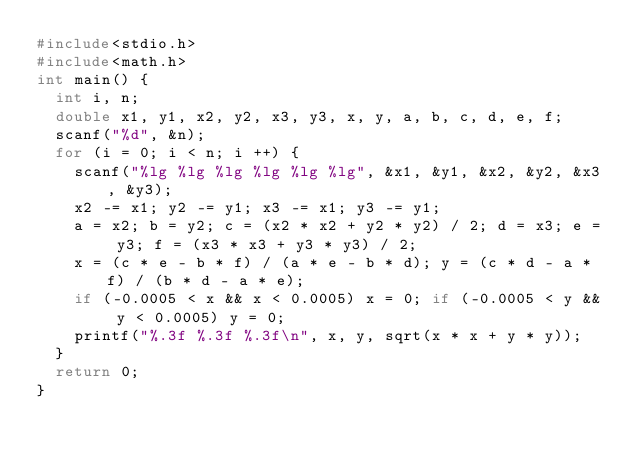<code> <loc_0><loc_0><loc_500><loc_500><_C_>#include<stdio.h>
#include<math.h>
int main() {
  int i, n;
  double x1, y1, x2, y2, x3, y3, x, y, a, b, c, d, e, f;
  scanf("%d", &n);
  for (i = 0; i < n; i ++) {
    scanf("%lg %lg %lg %lg %lg %lg", &x1, &y1, &x2, &y2, &x3, &y3);
    x2 -= x1; y2 -= y1; x3 -= x1; y3 -= y1;
    a = x2; b = y2; c = (x2 * x2 + y2 * y2) / 2; d = x3; e = y3; f = (x3 * x3 + y3 * y3) / 2;
    x = (c * e - b * f) / (a * e - b * d); y = (c * d - a * f) / (b * d - a * e);
    if (-0.0005 < x && x < 0.0005) x = 0; if (-0.0005 < y && y < 0.0005) y = 0;
    printf("%.3f %.3f %.3f\n", x, y, sqrt(x * x + y * y));
  }
  return 0;
}</code> 